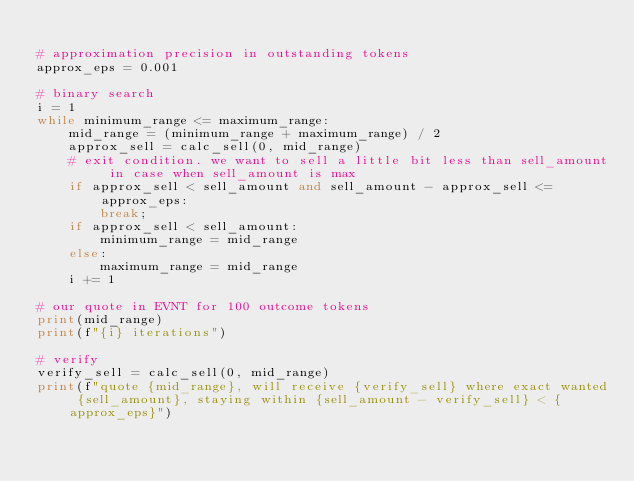<code> <loc_0><loc_0><loc_500><loc_500><_Python_>
# approximation precision in outstanding tokens
approx_eps = 0.001

# binary search
i = 1
while minimum_range <= maximum_range:
    mid_range = (minimum_range + maximum_range) / 2
    approx_sell = calc_sell(0, mid_range)
    # exit condition. we want to sell a little bit less than sell_amount in case when sell_amount is max
    if approx_sell < sell_amount and sell_amount - approx_sell <= approx_eps:
        break;
    if approx_sell < sell_amount:
        minimum_range = mid_range
    else:
        maximum_range = mid_range
    i += 1

# our quote in EVNT for 100 outcome tokens
print(mid_range)
print(f"{i} iterations")

# verify
verify_sell = calc_sell(0, mid_range)
print(f"quote {mid_range}, will receive {verify_sell} where exact wanted {sell_amount}, staying within {sell_amount - verify_sell} < {approx_eps}")</code> 